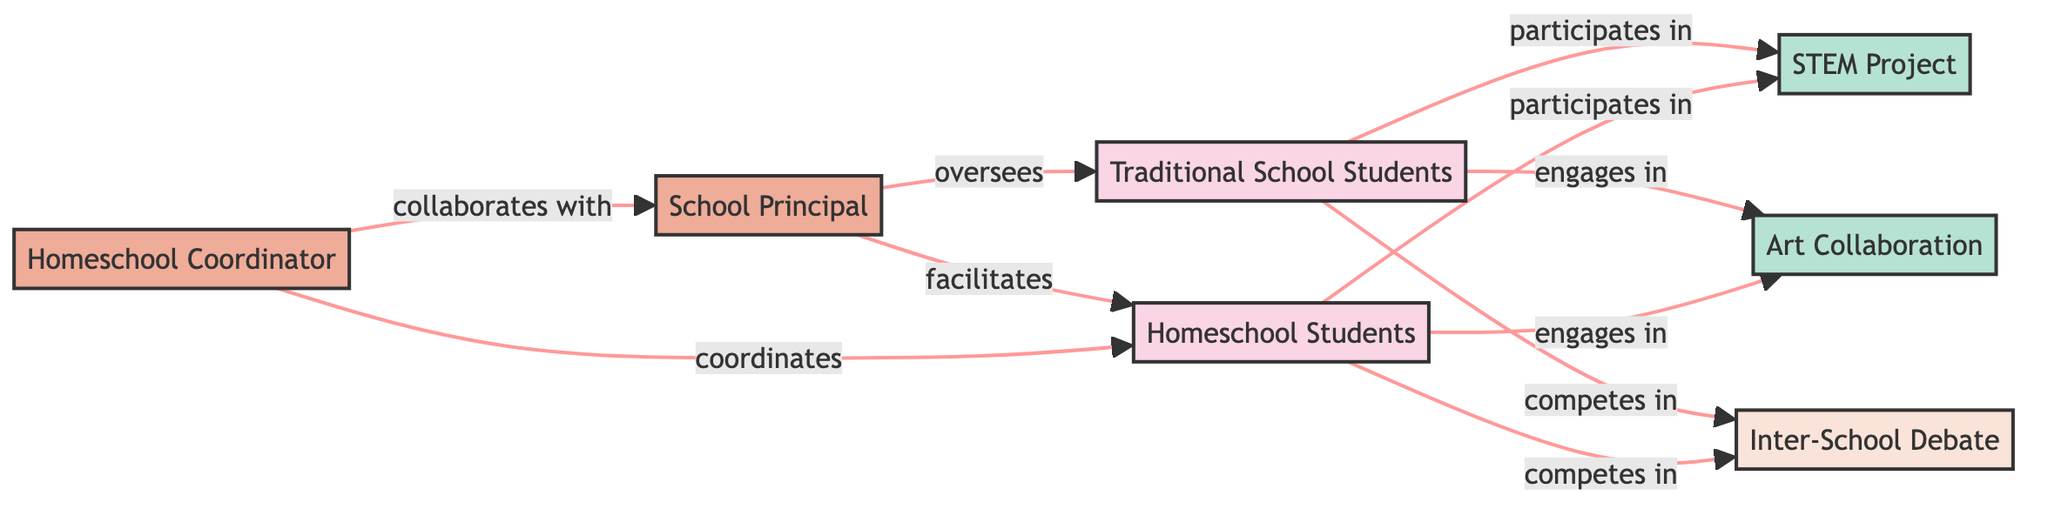What are the two groups in the diagram? The diagram lists "Traditional School Students" and "Homeschool Students" as the two groups. These are the main categories that represent the main participant types in the educational programs.
Answer: Traditional School Students, Homeschool Students How many individual nodes are represented in the diagram? Upon reviewing the nodes, there are two individual nodes: "School Principal" and "Homeschool Coordinator." These represent individuals overseeing or facilitating the projects and programs.
Answer: 2 Which project do both groups participate in? The diagram indicates that both "Traditional School Students" and "Homeschool Students" participate in the "STEM Project." The relationship is explicitly stated in the connections from both groups to the project node.
Answer: STEM Project What kind of relationship exists between the Homeschool Coordinator and the School Principal? The diagram shows that the Homeschool Coordinator "collaborates with" the School Principal, indicating a working relationship between these two individual nodes.
Answer: collaborates with Which competition involves both groups? According to the diagram, the "Inter-School Debate" is the competition that both groups compete in, resulting in direct connections to the competition node from both student groups.
Answer: Inter-School Debate How many edges are connecting the nodes in total? By counting the edges listed in the diagram, including all connections, there are ten edges. Each edge represents a relationship or participation between different nodes in the network.
Answer: 10 Which project do both groups engage in? The "Art Collaboration" is the project in which both "Traditional School Students" and "Homeschool Students" engage, as indicated by the connections from both groups to this project node in the diagram.
Answer: Art Collaboration Who oversees the traditional school students? The diagram specifies that the "School Principal" oversees the "Traditional School Students," indicating leadership and guidance in the activities represented.
Answer: School Principal 